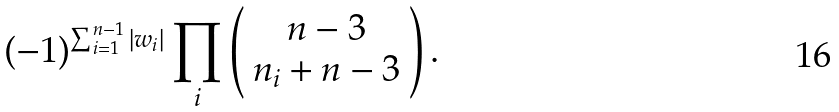Convert formula to latex. <formula><loc_0><loc_0><loc_500><loc_500>( - 1 ) ^ { \sum _ { i = 1 } ^ { n - 1 } | w _ { i } | } \prod _ { i } \left ( \begin{array} { c } n - 3 \\ n _ { i } + n - 3 \end{array} \right ) .</formula> 